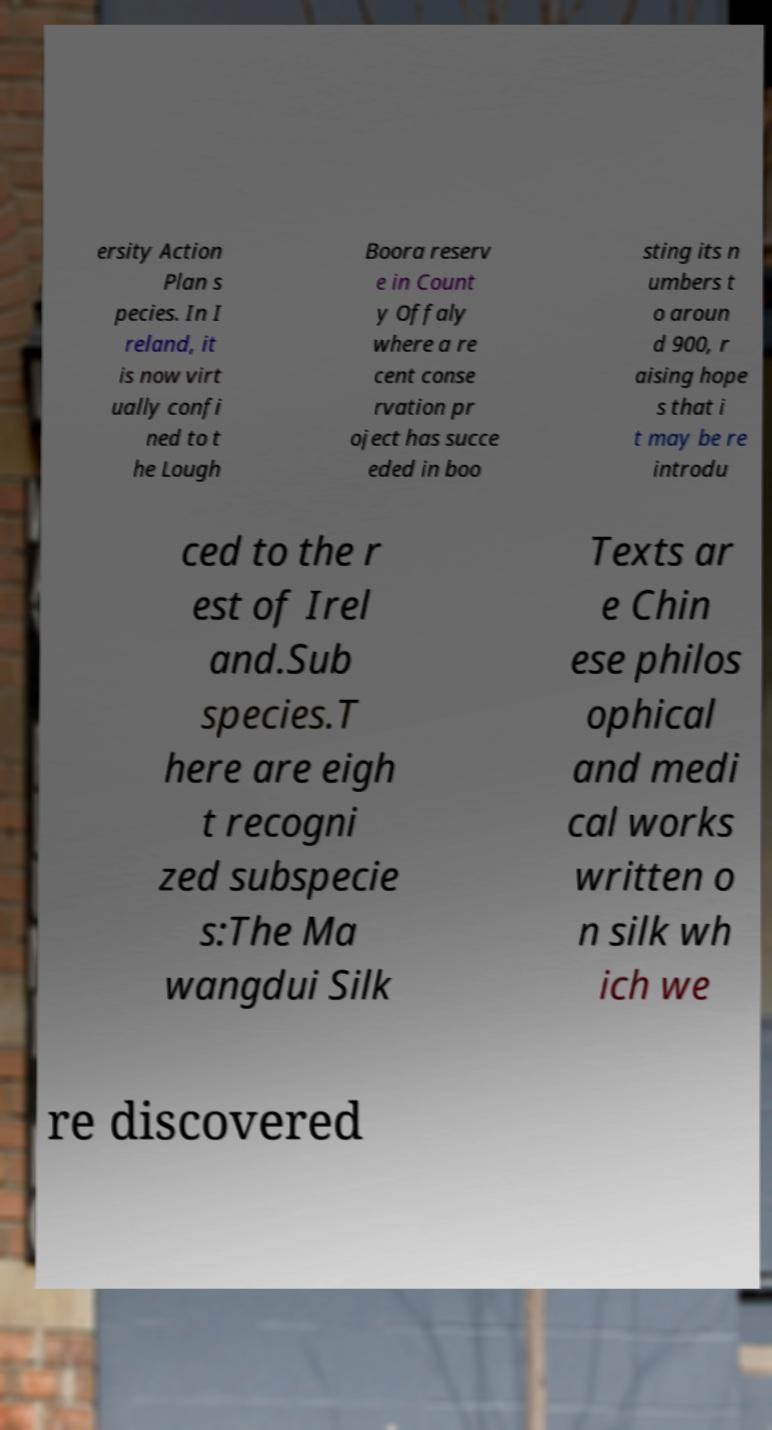Please identify and transcribe the text found in this image. ersity Action Plan s pecies. In I reland, it is now virt ually confi ned to t he Lough Boora reserv e in Count y Offaly where a re cent conse rvation pr oject has succe eded in boo sting its n umbers t o aroun d 900, r aising hope s that i t may be re introdu ced to the r est of Irel and.Sub species.T here are eigh t recogni zed subspecie s:The Ma wangdui Silk Texts ar e Chin ese philos ophical and medi cal works written o n silk wh ich we re discovered 